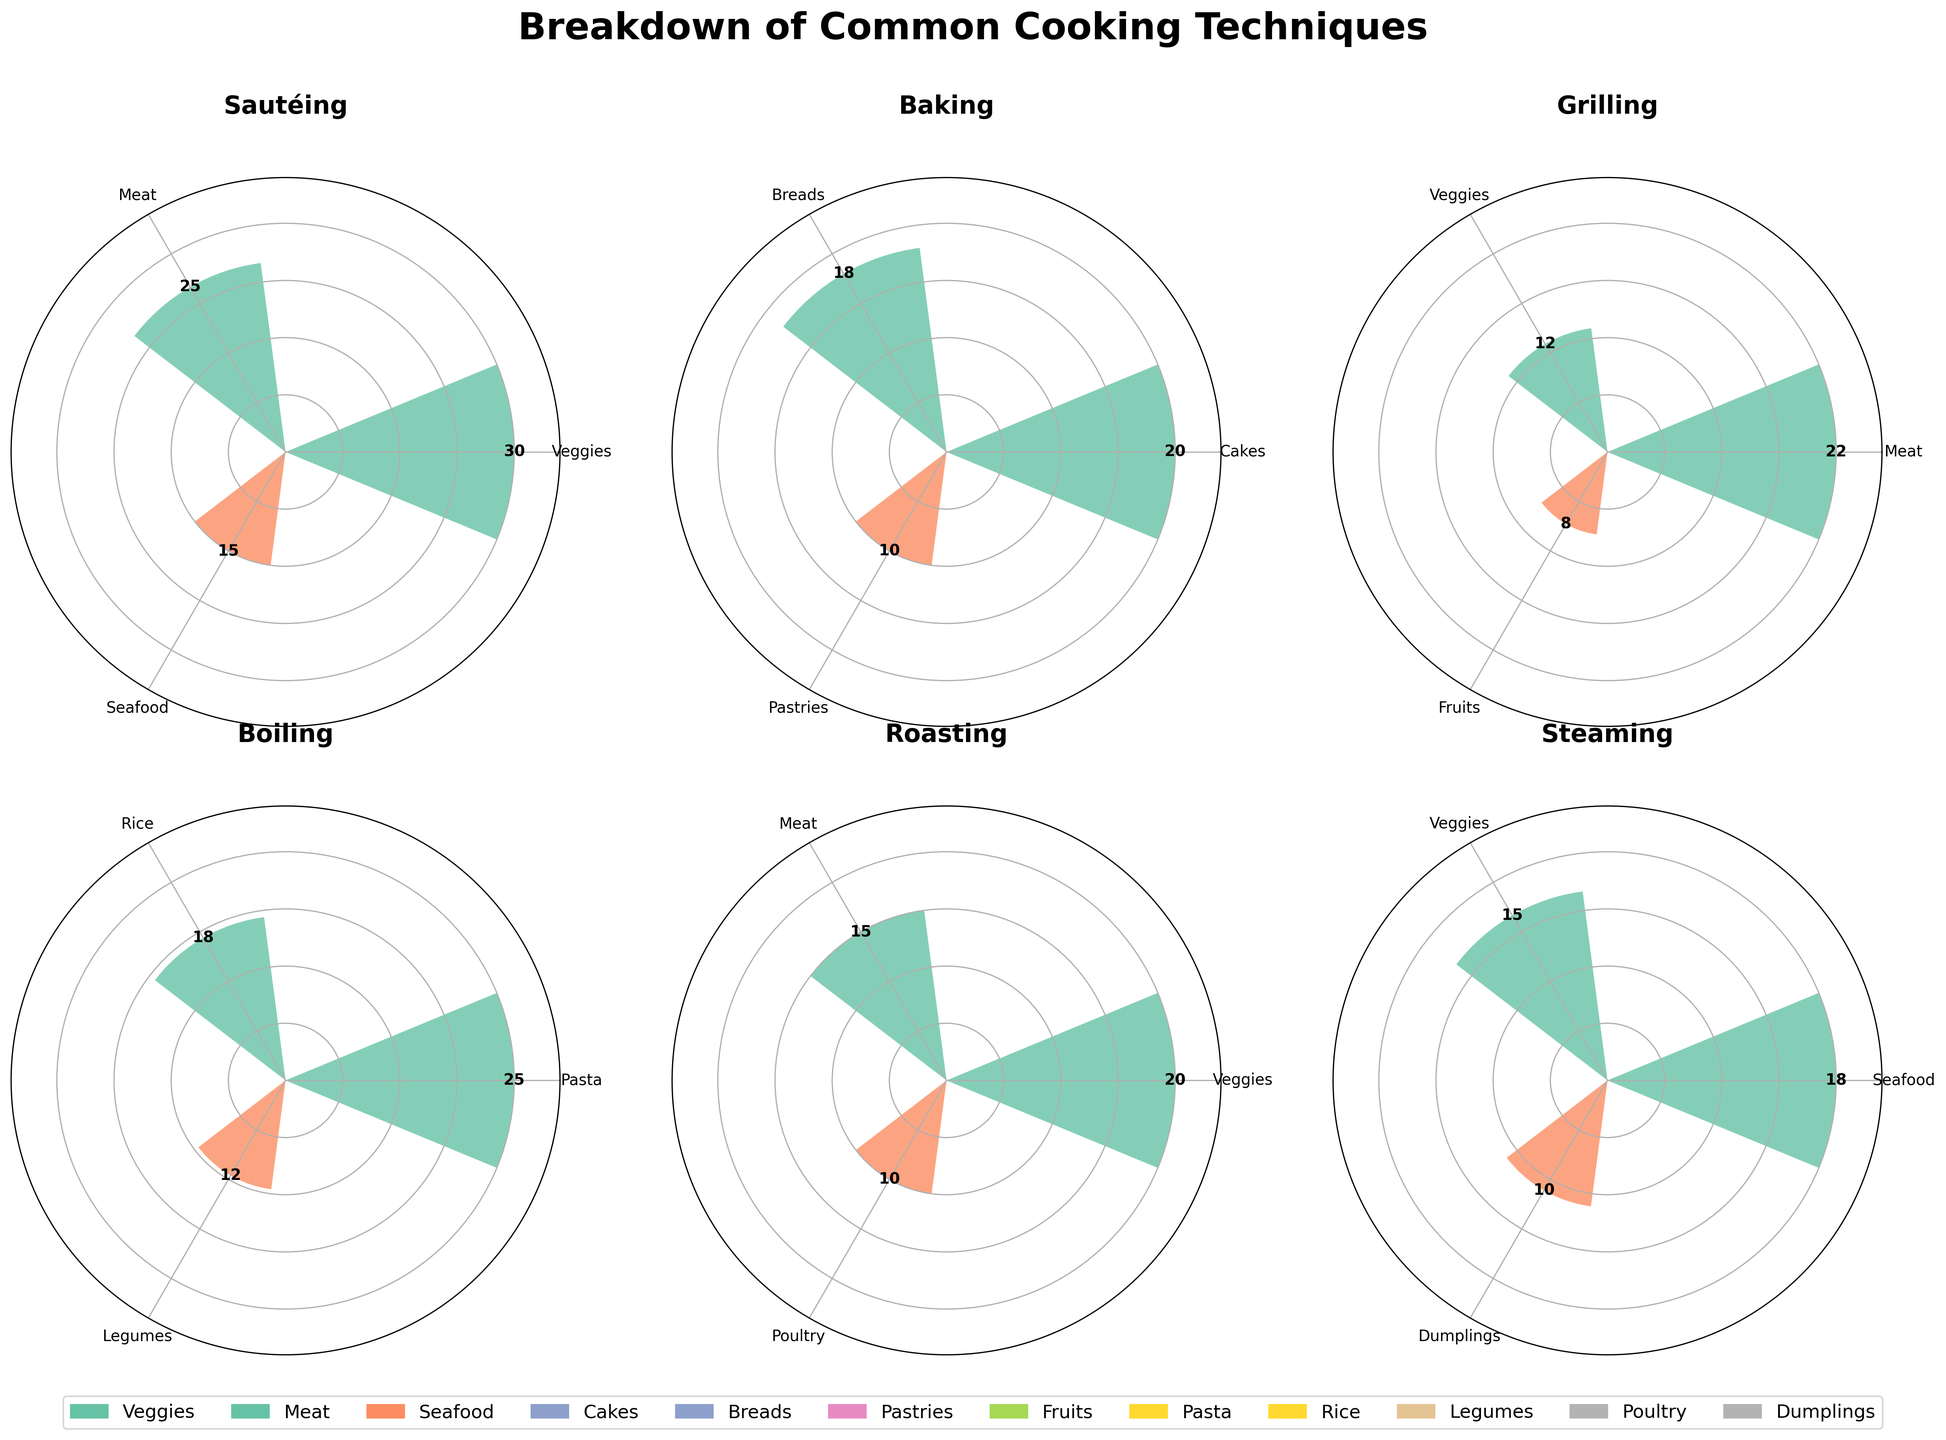What's the technique with the highest frequency of use for veggies? Based on the visual data, Sautéing for veggies has the highest frequency, shown by the largest bar in the Sautéing subplot for the Veggies category.
Answer: Sautéing Which category has the lowest frequency of use in the Grilling technique? For Grilling, the Fruits category has the lowest frequency of use, indicated by the smallest bar in the Grilling subplot for the Fruits category.
Answer: Fruits What is the total frequency of use for the Baking technique across all categories? Summing up the frequencies for Baking in Cakes (20), Breads (18), and Pastries (10) gives 20 + 18 + 10 = 48.
Answer: 48 Is the frequency of use for Boiling veggies higher than that for Roasting poultry? The frequency of use for Boiling veggies is not directly provided, but Roasting poultry has a frequency of 10. Comparison can be made using numbers stated in other categories for Boiling.
Answer: No What is the average frequency of use for the techniques involving Seafood? Sautéing Seafood (15), Steaming Seafood (18), averaging them gives (15 + 18)/2 = 16.5.
Answer: 16.5 Which technique has the smallest difference in frequency of use between its categories? Calculating differences: Sautéing Veggies-Meat = 30-25=5, Baking Cakes-Breads=20-18=2, Boiling Pasta-Rice=25-18=7. Baking has the smallest difference.
Answer: Baking What is the difference between the highest and lowest frequency of use for any one technique? For Sautéing, the max is 30 (Veggies) and min is 15 (Seafood), difference is 30-15=15.
Answer: 15 